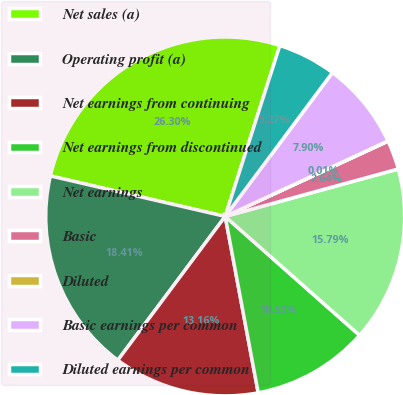Convert chart to OTSL. <chart><loc_0><loc_0><loc_500><loc_500><pie_chart><fcel>Net sales (a)<fcel>Operating profit (a)<fcel>Net earnings from continuing<fcel>Net earnings from discontinued<fcel>Net earnings<fcel>Basic<fcel>Diluted<fcel>Basic earnings per common<fcel>Diluted earnings per common<nl><fcel>26.31%<fcel>18.42%<fcel>13.16%<fcel>10.53%<fcel>15.79%<fcel>2.64%<fcel>0.01%<fcel>7.9%<fcel>5.27%<nl></chart> 